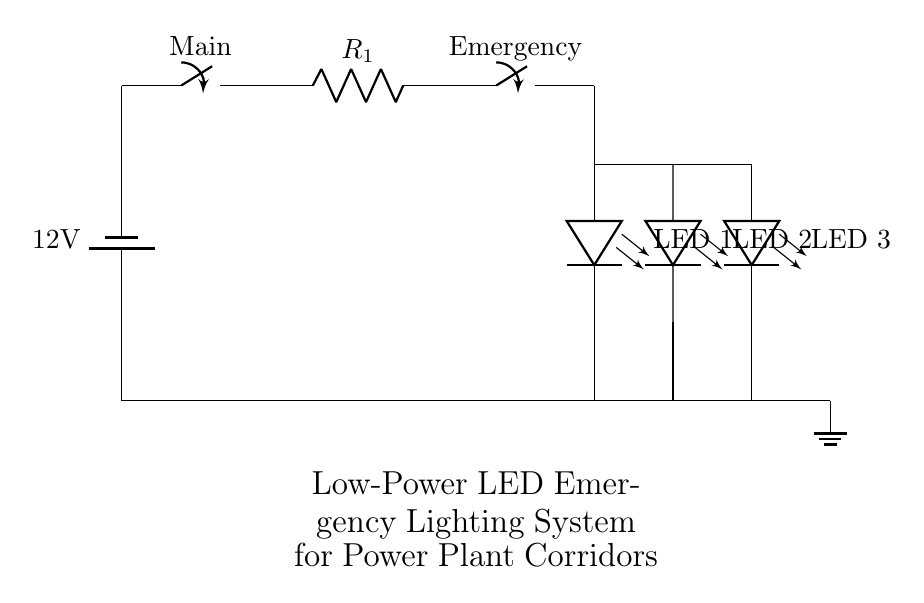What is the voltage of the battery in this circuit? The voltage is indicated on the battery symbol, which is labeled as 12 volts.
Answer: 12 volts What components are in this circuit? The components visible in this circuit include a battery, a main switch, a current limiting resistor, an emergency switch, and multiple LEDs.
Answer: Battery, switch, resistor, LEDs How many LEDs are in this circuit? There are three LED components as shown by the symbols labeled LED 1, LED 2, and LED 3.
Answer: Three What is the state of the emergency switch when the system is powered? The emergency switch is configured as normally closed, which means it allows current to flow when no external force is applied to open it.
Answer: Normally closed If the main switch is open, will the LEDs light up? No, if the main switch is open, the entire circuit is interrupted, preventing current from reaching the LEDs.
Answer: No What role does the current limiting resistor play in this circuit? The current limiting resistor is essential to prevent excessive current from flowing through the LEDs, ensuring they operate within safe limits.
Answer: Current limiting What will happen if the emergency switch is opened? Opening the emergency switch will break the circuit path for the LEDs, resulting in no light output, unless other conditions are met.
Answer: No light output 